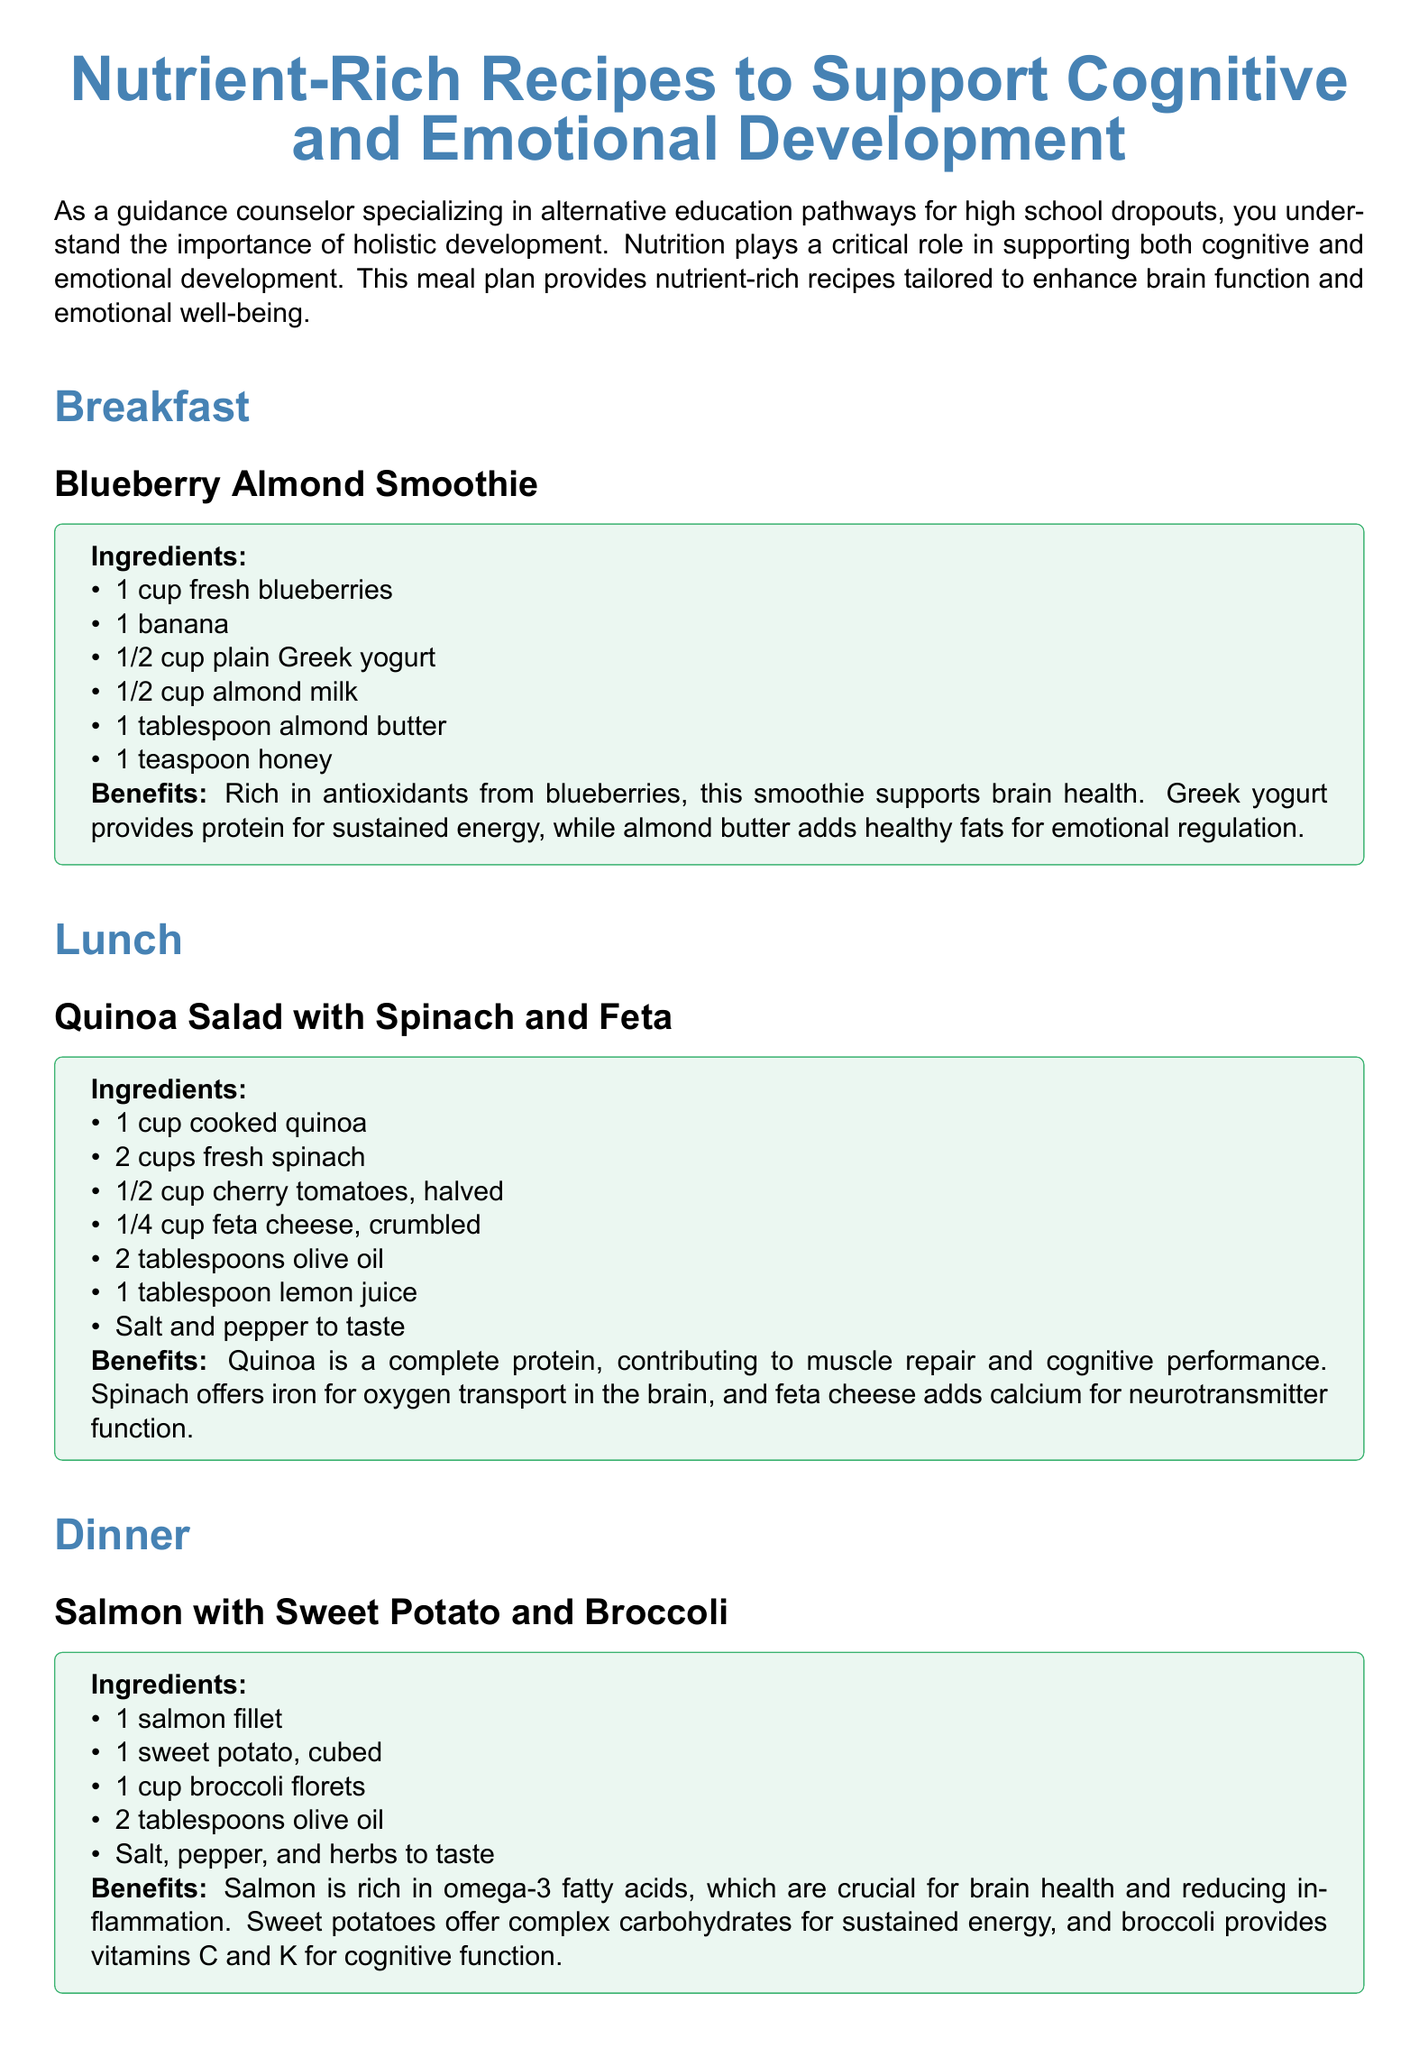What is the first recipe listed? The first recipe mentioned in the document is titled "Blueberry Almond Smoothie."
Answer: Blueberry Almond Smoothie How many ingredients are in the lunch recipe? The lunch recipe "Quinoa Salad with Spinach and Feta" lists a total of seven ingredients.
Answer: 7 What type of milk is used in the smoothie recipe? The recipe for the "Blueberry Almond Smoothie" specifically calls for almond milk as one of the ingredients.
Answer: almond milk What are the health benefits of salmon according to the document? The document states that salmon is rich in omega-3 fatty acids, which are crucial for brain health and reducing inflammation.
Answer: omega-3 fatty acids How much olive oil is required for the dinner recipe? The recipe for dinner indicates that 2 tablespoons of olive oil are needed.
Answer: 2 tablespoons What does quinoa offer in terms of nutritional benefits? Quinoa is a complete protein, which contributes to muscle repair and cognitive performance.
Answer: complete protein Which snack includes dark chocolate? The snack recipe "Trail Mix" includes dark chocolate chips amongst its ingredients.
Answer: Trail Mix What vitamin is found in broccoli as per the document? According to the document, broccoli provides vitamins C and K, supporting cognitive function.
Answer: vitamins C and K 